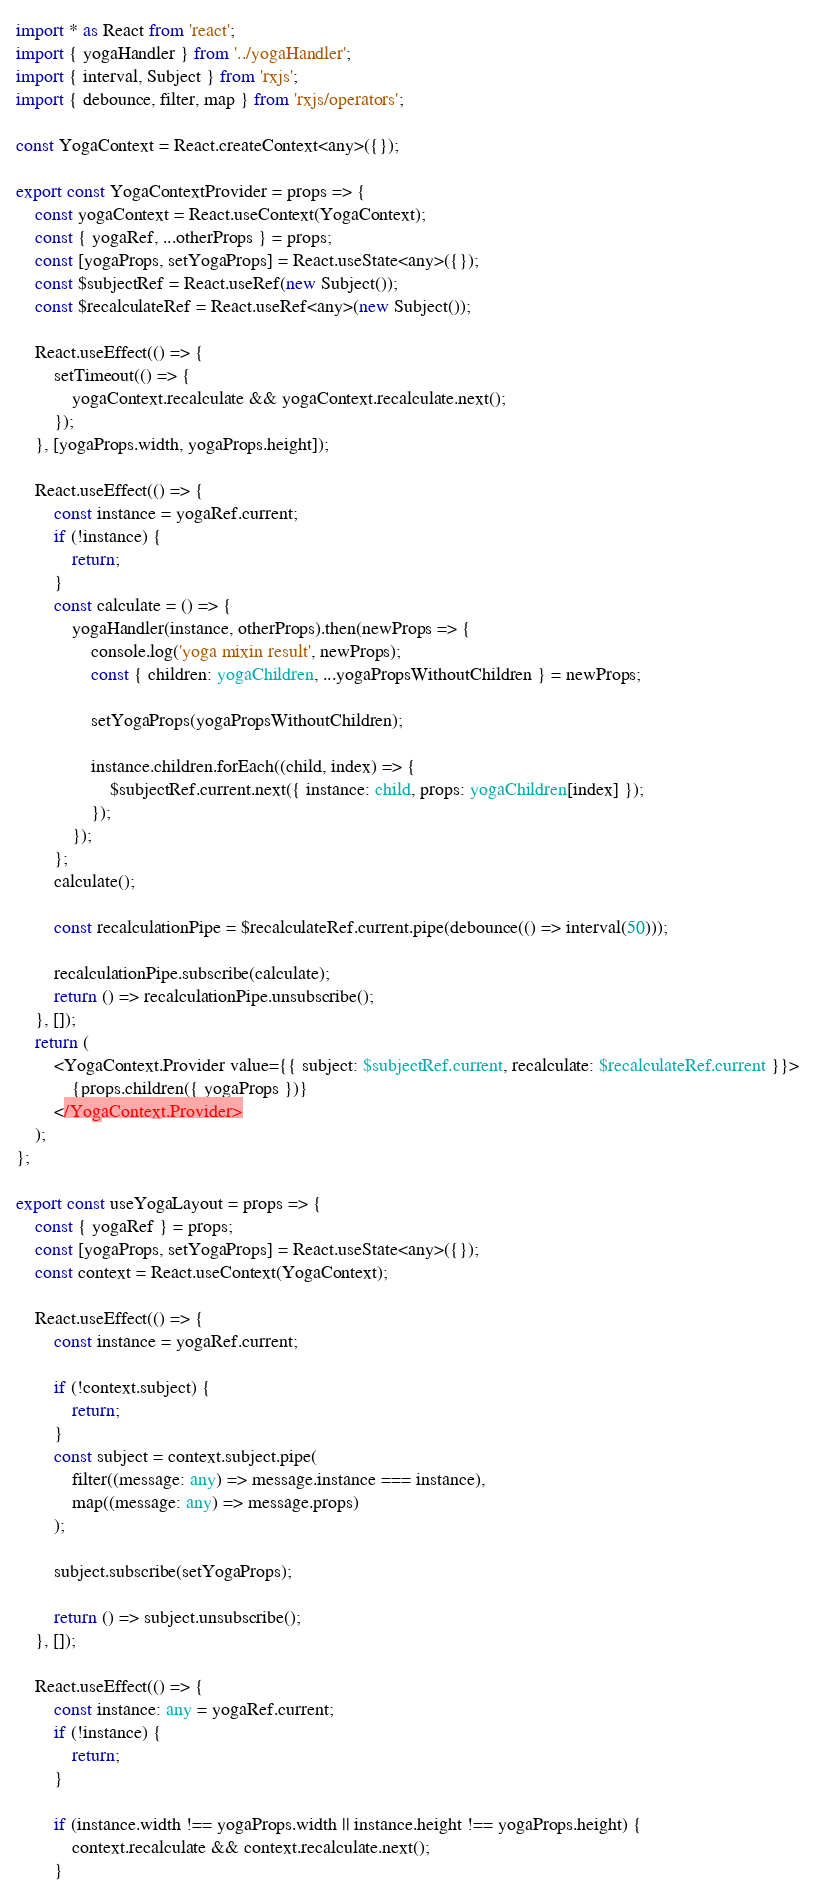Convert code to text. <code><loc_0><loc_0><loc_500><loc_500><_TypeScript_>import * as React from 'react';
import { yogaHandler } from '../yogaHandler';
import { interval, Subject } from 'rxjs';
import { debounce, filter, map } from 'rxjs/operators';

const YogaContext = React.createContext<any>({});

export const YogaContextProvider = props => {
    const yogaContext = React.useContext(YogaContext);
    const { yogaRef, ...otherProps } = props;
    const [yogaProps, setYogaProps] = React.useState<any>({});
    const $subjectRef = React.useRef(new Subject());
    const $recalculateRef = React.useRef<any>(new Subject());

    React.useEffect(() => {
        setTimeout(() => {
            yogaContext.recalculate && yogaContext.recalculate.next();
        });
    }, [yogaProps.width, yogaProps.height]);

    React.useEffect(() => {
        const instance = yogaRef.current;
        if (!instance) {
            return;
        }
        const calculate = () => {
            yogaHandler(instance, otherProps).then(newProps => {
                console.log('yoga mixin result', newProps);
                const { children: yogaChildren, ...yogaPropsWithoutChildren } = newProps;

                setYogaProps(yogaPropsWithoutChildren);

                instance.children.forEach((child, index) => {
                    $subjectRef.current.next({ instance: child, props: yogaChildren[index] });
                });
            });
        };
        calculate();

        const recalculationPipe = $recalculateRef.current.pipe(debounce(() => interval(50)));

        recalculationPipe.subscribe(calculate);
        return () => recalculationPipe.unsubscribe();
    }, []);
    return (
        <YogaContext.Provider value={{ subject: $subjectRef.current, recalculate: $recalculateRef.current }}>
            {props.children({ yogaProps })}
        </YogaContext.Provider>
    );
};

export const useYogaLayout = props => {
    const { yogaRef } = props;
    const [yogaProps, setYogaProps] = React.useState<any>({});
    const context = React.useContext(YogaContext);

    React.useEffect(() => {
        const instance = yogaRef.current;

        if (!context.subject) {
            return;
        }
        const subject = context.subject.pipe(
            filter((message: any) => message.instance === instance),
            map((message: any) => message.props)
        );

        subject.subscribe(setYogaProps);

        return () => subject.unsubscribe();
    }, []);

    React.useEffect(() => {
        const instance: any = yogaRef.current;
        if (!instance) {
            return;
        }

        if (instance.width !== yogaProps.width || instance.height !== yogaProps.height) {
            context.recalculate && context.recalculate.next();
        }</code> 